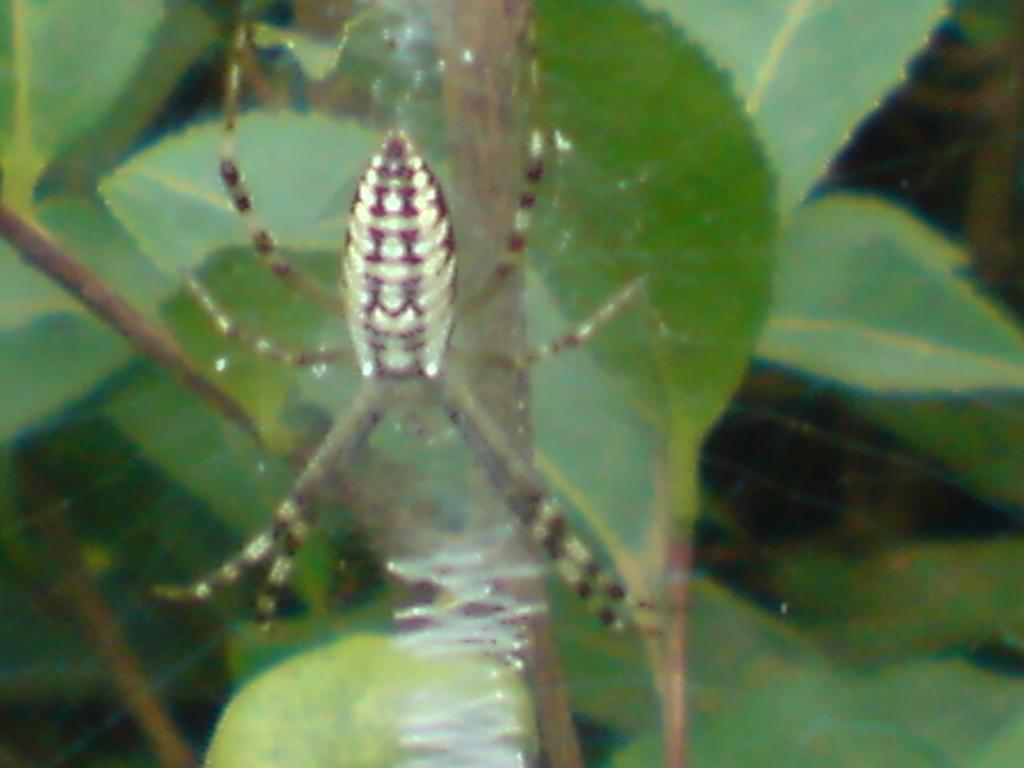What is the main subject in the center of the image? There is a spider in the center of the image. What can be seen in the background of the image? There are leaves in the background of the image. How many beds are visible in the image? There are no beds present in the image. What type of curve can be seen on the spider's body in the image? The image does not show a close-up view of the spider's body, so it is not possible to determine the presence of any curves. 